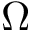<formula> <loc_0><loc_0><loc_500><loc_500>\Omega</formula> 